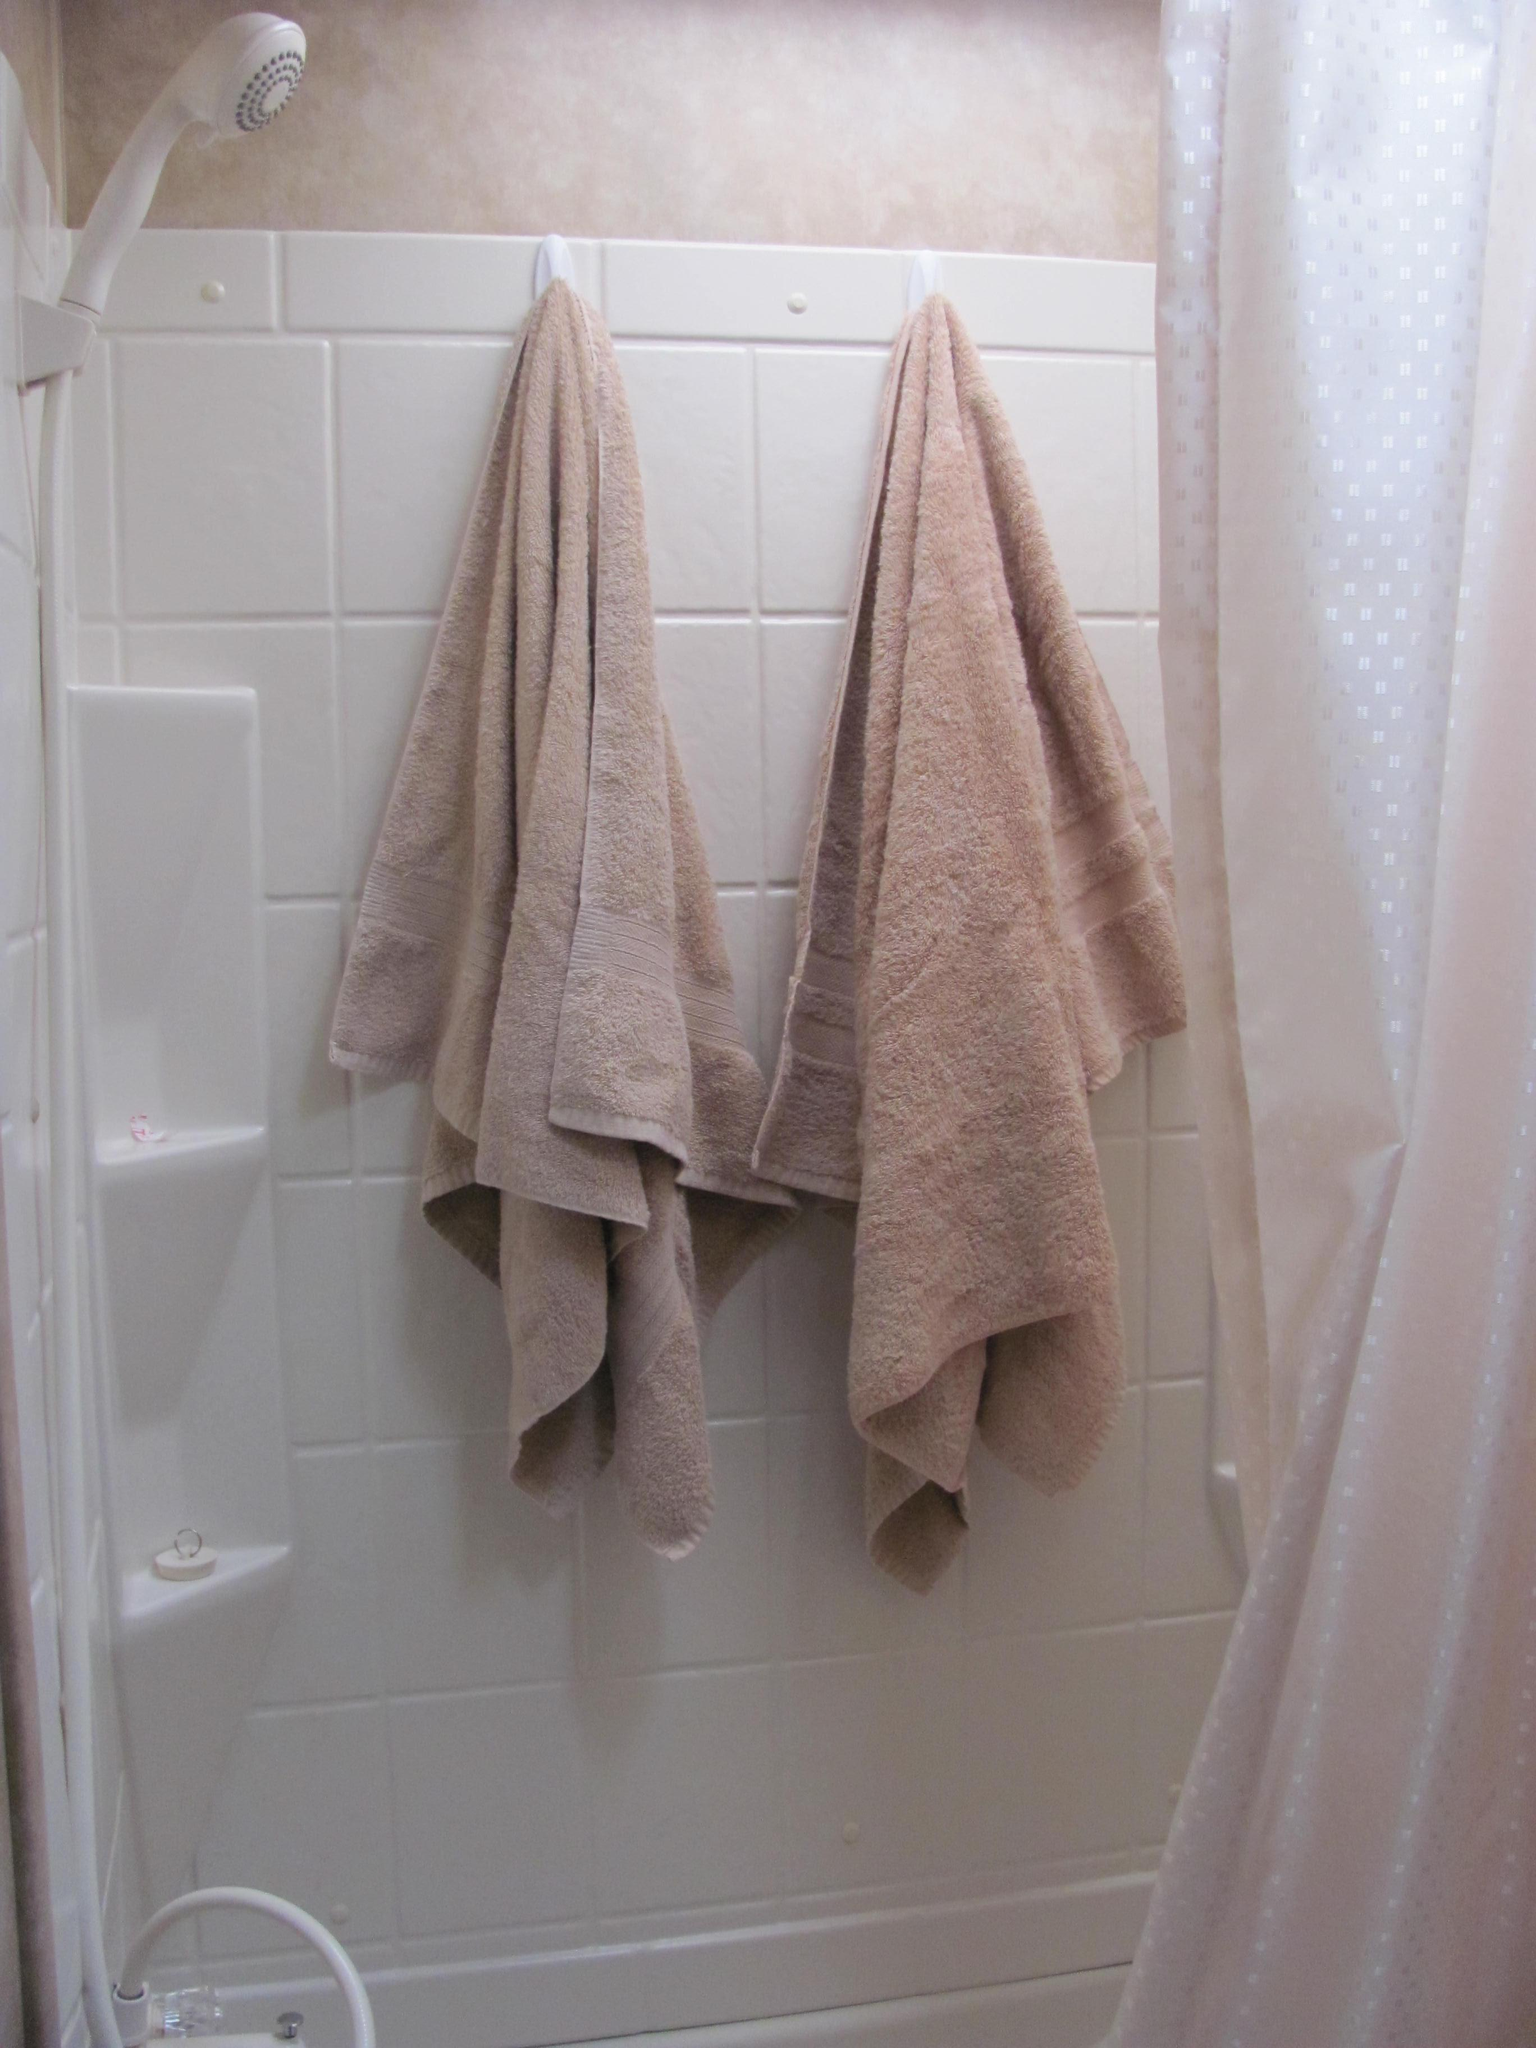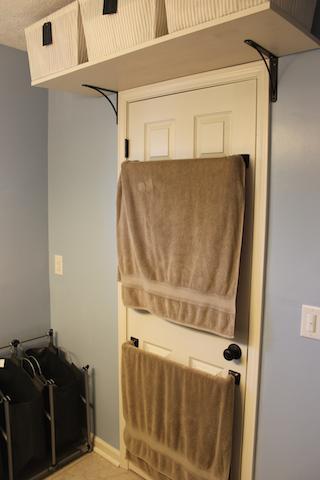The first image is the image on the left, the second image is the image on the right. Considering the images on both sides, is "Exactly two towels hang from hooks in one image." valid? Answer yes or no. Yes. 